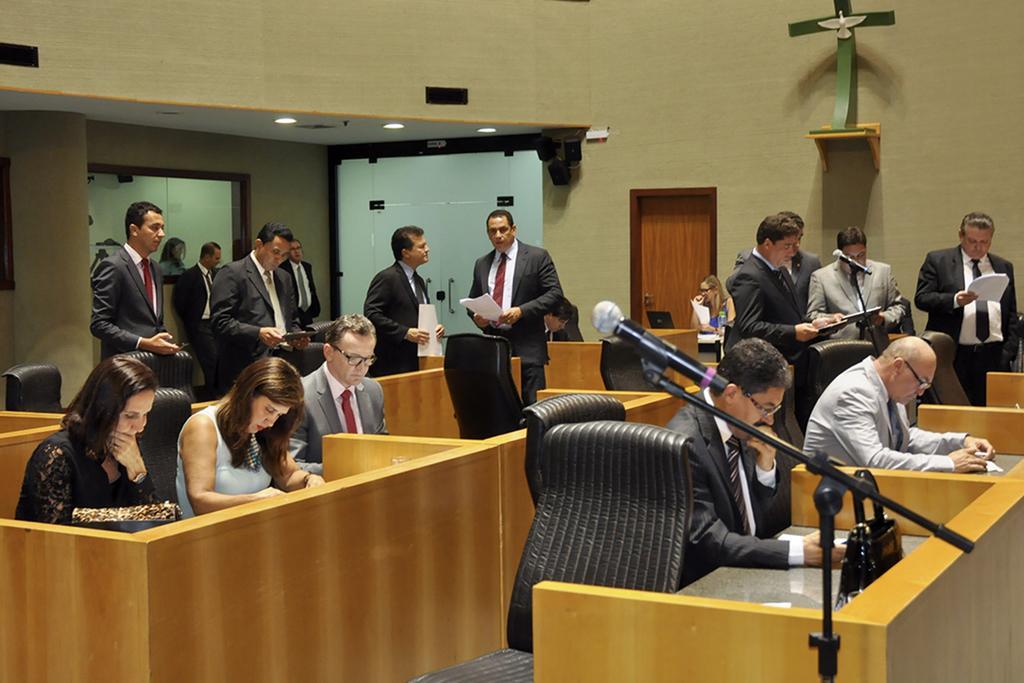Could you give a brief overview of what you see in this image? In this image few persons are sitting on the chairs before a table. Few persons wearing suit and tie are standing. A woman holding a paper is sitting before a table having a laptop on it. There is a idol kept on the shelf which is attached to the wall having doors. Few persons are standing before a mike stand. 